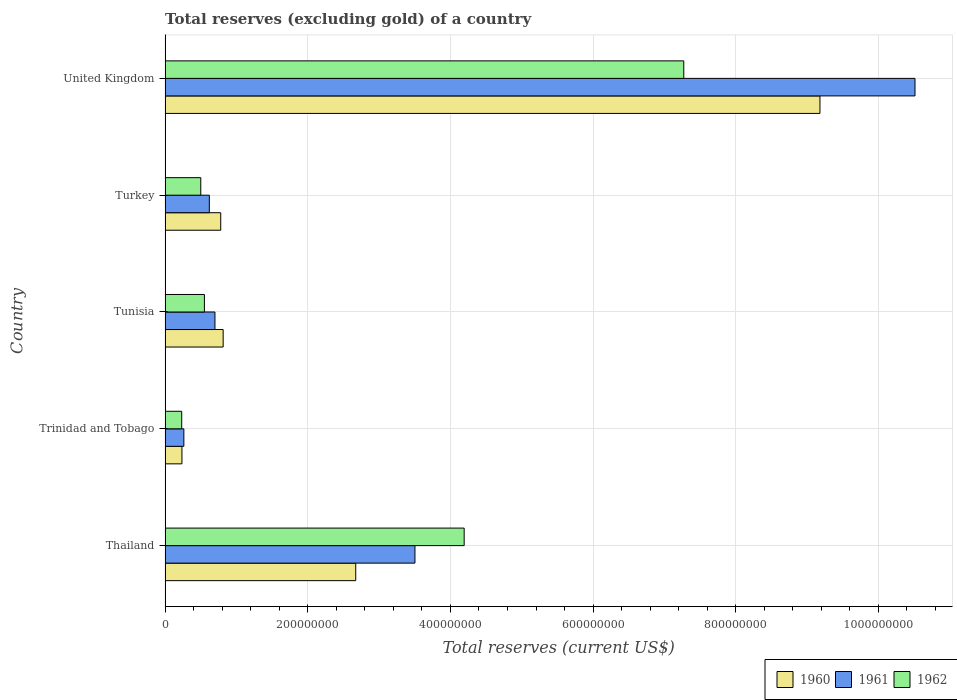How many groups of bars are there?
Your answer should be very brief. 5. Are the number of bars per tick equal to the number of legend labels?
Make the answer very short. Yes. Are the number of bars on each tick of the Y-axis equal?
Offer a very short reply. Yes. What is the label of the 3rd group of bars from the top?
Your answer should be very brief. Tunisia. What is the total reserves (excluding gold) in 1962 in Tunisia?
Your answer should be very brief. 5.51e+07. Across all countries, what is the maximum total reserves (excluding gold) in 1960?
Your response must be concise. 9.18e+08. Across all countries, what is the minimum total reserves (excluding gold) in 1960?
Your answer should be very brief. 2.36e+07. In which country was the total reserves (excluding gold) in 1962 maximum?
Provide a succinct answer. United Kingdom. In which country was the total reserves (excluding gold) in 1962 minimum?
Provide a succinct answer. Trinidad and Tobago. What is the total total reserves (excluding gold) in 1960 in the graph?
Provide a succinct answer. 1.37e+09. What is the difference between the total reserves (excluding gold) in 1961 in Trinidad and Tobago and that in United Kingdom?
Your answer should be very brief. -1.02e+09. What is the difference between the total reserves (excluding gold) in 1960 in Trinidad and Tobago and the total reserves (excluding gold) in 1961 in Turkey?
Your answer should be compact. -3.84e+07. What is the average total reserves (excluding gold) in 1962 per country?
Make the answer very short. 2.55e+08. What is the difference between the total reserves (excluding gold) in 1960 and total reserves (excluding gold) in 1961 in Thailand?
Offer a very short reply. -8.30e+07. In how many countries, is the total reserves (excluding gold) in 1962 greater than 80000000 US$?
Offer a terse response. 2. What is the ratio of the total reserves (excluding gold) in 1960 in Thailand to that in Turkey?
Your answer should be very brief. 3.43. What is the difference between the highest and the second highest total reserves (excluding gold) in 1962?
Offer a terse response. 3.08e+08. What is the difference between the highest and the lowest total reserves (excluding gold) in 1960?
Your response must be concise. 8.94e+08. How many countries are there in the graph?
Offer a very short reply. 5. Are the values on the major ticks of X-axis written in scientific E-notation?
Your answer should be very brief. No. Does the graph contain any zero values?
Make the answer very short. No. Does the graph contain grids?
Offer a very short reply. Yes. How many legend labels are there?
Offer a terse response. 3. What is the title of the graph?
Offer a very short reply. Total reserves (excluding gold) of a country. Does "2010" appear as one of the legend labels in the graph?
Make the answer very short. No. What is the label or title of the X-axis?
Keep it short and to the point. Total reserves (current US$). What is the Total reserves (current US$) of 1960 in Thailand?
Your answer should be compact. 2.67e+08. What is the Total reserves (current US$) of 1961 in Thailand?
Ensure brevity in your answer.  3.50e+08. What is the Total reserves (current US$) in 1962 in Thailand?
Keep it short and to the point. 4.19e+08. What is the Total reserves (current US$) in 1960 in Trinidad and Tobago?
Offer a very short reply. 2.36e+07. What is the Total reserves (current US$) of 1961 in Trinidad and Tobago?
Your answer should be compact. 2.63e+07. What is the Total reserves (current US$) of 1962 in Trinidad and Tobago?
Your answer should be compact. 2.33e+07. What is the Total reserves (current US$) of 1960 in Tunisia?
Your response must be concise. 8.14e+07. What is the Total reserves (current US$) in 1961 in Tunisia?
Offer a very short reply. 6.99e+07. What is the Total reserves (current US$) in 1962 in Tunisia?
Offer a terse response. 5.51e+07. What is the Total reserves (current US$) in 1960 in Turkey?
Provide a short and direct response. 7.80e+07. What is the Total reserves (current US$) in 1961 in Turkey?
Provide a succinct answer. 6.20e+07. What is the Total reserves (current US$) in 1960 in United Kingdom?
Your answer should be compact. 9.18e+08. What is the Total reserves (current US$) of 1961 in United Kingdom?
Keep it short and to the point. 1.05e+09. What is the Total reserves (current US$) in 1962 in United Kingdom?
Your answer should be very brief. 7.27e+08. Across all countries, what is the maximum Total reserves (current US$) of 1960?
Offer a very short reply. 9.18e+08. Across all countries, what is the maximum Total reserves (current US$) of 1961?
Your response must be concise. 1.05e+09. Across all countries, what is the maximum Total reserves (current US$) in 1962?
Ensure brevity in your answer.  7.27e+08. Across all countries, what is the minimum Total reserves (current US$) in 1960?
Keep it short and to the point. 2.36e+07. Across all countries, what is the minimum Total reserves (current US$) of 1961?
Make the answer very short. 2.63e+07. Across all countries, what is the minimum Total reserves (current US$) of 1962?
Offer a terse response. 2.33e+07. What is the total Total reserves (current US$) of 1960 in the graph?
Offer a terse response. 1.37e+09. What is the total Total reserves (current US$) of 1961 in the graph?
Provide a succinct answer. 1.56e+09. What is the total Total reserves (current US$) in 1962 in the graph?
Your answer should be compact. 1.27e+09. What is the difference between the Total reserves (current US$) in 1960 in Thailand and that in Trinidad and Tobago?
Provide a succinct answer. 2.44e+08. What is the difference between the Total reserves (current US$) of 1961 in Thailand and that in Trinidad and Tobago?
Your answer should be compact. 3.24e+08. What is the difference between the Total reserves (current US$) in 1962 in Thailand and that in Trinidad and Tobago?
Give a very brief answer. 3.96e+08. What is the difference between the Total reserves (current US$) in 1960 in Thailand and that in Tunisia?
Your response must be concise. 1.86e+08. What is the difference between the Total reserves (current US$) of 1961 in Thailand and that in Tunisia?
Offer a very short reply. 2.80e+08. What is the difference between the Total reserves (current US$) in 1962 in Thailand and that in Tunisia?
Give a very brief answer. 3.64e+08. What is the difference between the Total reserves (current US$) of 1960 in Thailand and that in Turkey?
Make the answer very short. 1.89e+08. What is the difference between the Total reserves (current US$) of 1961 in Thailand and that in Turkey?
Offer a very short reply. 2.88e+08. What is the difference between the Total reserves (current US$) in 1962 in Thailand and that in Turkey?
Offer a very short reply. 3.69e+08. What is the difference between the Total reserves (current US$) of 1960 in Thailand and that in United Kingdom?
Provide a succinct answer. -6.51e+08. What is the difference between the Total reserves (current US$) of 1961 in Thailand and that in United Kingdom?
Offer a very short reply. -7.01e+08. What is the difference between the Total reserves (current US$) of 1962 in Thailand and that in United Kingdom?
Keep it short and to the point. -3.08e+08. What is the difference between the Total reserves (current US$) of 1960 in Trinidad and Tobago and that in Tunisia?
Give a very brief answer. -5.78e+07. What is the difference between the Total reserves (current US$) in 1961 in Trinidad and Tobago and that in Tunisia?
Your response must be concise. -4.36e+07. What is the difference between the Total reserves (current US$) in 1962 in Trinidad and Tobago and that in Tunisia?
Ensure brevity in your answer.  -3.18e+07. What is the difference between the Total reserves (current US$) in 1960 in Trinidad and Tobago and that in Turkey?
Offer a terse response. -5.44e+07. What is the difference between the Total reserves (current US$) of 1961 in Trinidad and Tobago and that in Turkey?
Ensure brevity in your answer.  -3.57e+07. What is the difference between the Total reserves (current US$) in 1962 in Trinidad and Tobago and that in Turkey?
Provide a short and direct response. -2.67e+07. What is the difference between the Total reserves (current US$) in 1960 in Trinidad and Tobago and that in United Kingdom?
Your answer should be compact. -8.94e+08. What is the difference between the Total reserves (current US$) of 1961 in Trinidad and Tobago and that in United Kingdom?
Ensure brevity in your answer.  -1.02e+09. What is the difference between the Total reserves (current US$) in 1962 in Trinidad and Tobago and that in United Kingdom?
Your response must be concise. -7.04e+08. What is the difference between the Total reserves (current US$) in 1960 in Tunisia and that in Turkey?
Keep it short and to the point. 3.40e+06. What is the difference between the Total reserves (current US$) of 1961 in Tunisia and that in Turkey?
Give a very brief answer. 7.90e+06. What is the difference between the Total reserves (current US$) of 1962 in Tunisia and that in Turkey?
Offer a terse response. 5.10e+06. What is the difference between the Total reserves (current US$) in 1960 in Tunisia and that in United Kingdom?
Offer a terse response. -8.37e+08. What is the difference between the Total reserves (current US$) of 1961 in Tunisia and that in United Kingdom?
Provide a short and direct response. -9.81e+08. What is the difference between the Total reserves (current US$) in 1962 in Tunisia and that in United Kingdom?
Offer a terse response. -6.72e+08. What is the difference between the Total reserves (current US$) of 1960 in Turkey and that in United Kingdom?
Your answer should be compact. -8.40e+08. What is the difference between the Total reserves (current US$) of 1961 in Turkey and that in United Kingdom?
Keep it short and to the point. -9.89e+08. What is the difference between the Total reserves (current US$) in 1962 in Turkey and that in United Kingdom?
Give a very brief answer. -6.77e+08. What is the difference between the Total reserves (current US$) of 1960 in Thailand and the Total reserves (current US$) of 1961 in Trinidad and Tobago?
Your response must be concise. 2.41e+08. What is the difference between the Total reserves (current US$) of 1960 in Thailand and the Total reserves (current US$) of 1962 in Trinidad and Tobago?
Provide a succinct answer. 2.44e+08. What is the difference between the Total reserves (current US$) of 1961 in Thailand and the Total reserves (current US$) of 1962 in Trinidad and Tobago?
Your answer should be compact. 3.27e+08. What is the difference between the Total reserves (current US$) in 1960 in Thailand and the Total reserves (current US$) in 1961 in Tunisia?
Your response must be concise. 1.97e+08. What is the difference between the Total reserves (current US$) of 1960 in Thailand and the Total reserves (current US$) of 1962 in Tunisia?
Keep it short and to the point. 2.12e+08. What is the difference between the Total reserves (current US$) of 1961 in Thailand and the Total reserves (current US$) of 1962 in Tunisia?
Provide a short and direct response. 2.95e+08. What is the difference between the Total reserves (current US$) of 1960 in Thailand and the Total reserves (current US$) of 1961 in Turkey?
Ensure brevity in your answer.  2.05e+08. What is the difference between the Total reserves (current US$) in 1960 in Thailand and the Total reserves (current US$) in 1962 in Turkey?
Provide a short and direct response. 2.17e+08. What is the difference between the Total reserves (current US$) in 1961 in Thailand and the Total reserves (current US$) in 1962 in Turkey?
Your answer should be very brief. 3.00e+08. What is the difference between the Total reserves (current US$) in 1960 in Thailand and the Total reserves (current US$) in 1961 in United Kingdom?
Your response must be concise. -7.84e+08. What is the difference between the Total reserves (current US$) of 1960 in Thailand and the Total reserves (current US$) of 1962 in United Kingdom?
Your answer should be compact. -4.60e+08. What is the difference between the Total reserves (current US$) in 1961 in Thailand and the Total reserves (current US$) in 1962 in United Kingdom?
Your answer should be compact. -3.77e+08. What is the difference between the Total reserves (current US$) of 1960 in Trinidad and Tobago and the Total reserves (current US$) of 1961 in Tunisia?
Provide a succinct answer. -4.63e+07. What is the difference between the Total reserves (current US$) in 1960 in Trinidad and Tobago and the Total reserves (current US$) in 1962 in Tunisia?
Your response must be concise. -3.15e+07. What is the difference between the Total reserves (current US$) of 1961 in Trinidad and Tobago and the Total reserves (current US$) of 1962 in Tunisia?
Make the answer very short. -2.88e+07. What is the difference between the Total reserves (current US$) of 1960 in Trinidad and Tobago and the Total reserves (current US$) of 1961 in Turkey?
Ensure brevity in your answer.  -3.84e+07. What is the difference between the Total reserves (current US$) of 1960 in Trinidad and Tobago and the Total reserves (current US$) of 1962 in Turkey?
Provide a short and direct response. -2.64e+07. What is the difference between the Total reserves (current US$) in 1961 in Trinidad and Tobago and the Total reserves (current US$) in 1962 in Turkey?
Give a very brief answer. -2.37e+07. What is the difference between the Total reserves (current US$) of 1960 in Trinidad and Tobago and the Total reserves (current US$) of 1961 in United Kingdom?
Your answer should be compact. -1.03e+09. What is the difference between the Total reserves (current US$) in 1960 in Trinidad and Tobago and the Total reserves (current US$) in 1962 in United Kingdom?
Your answer should be very brief. -7.04e+08. What is the difference between the Total reserves (current US$) of 1961 in Trinidad and Tobago and the Total reserves (current US$) of 1962 in United Kingdom?
Your answer should be very brief. -7.01e+08. What is the difference between the Total reserves (current US$) in 1960 in Tunisia and the Total reserves (current US$) in 1961 in Turkey?
Your answer should be very brief. 1.94e+07. What is the difference between the Total reserves (current US$) of 1960 in Tunisia and the Total reserves (current US$) of 1962 in Turkey?
Your answer should be compact. 3.14e+07. What is the difference between the Total reserves (current US$) in 1961 in Tunisia and the Total reserves (current US$) in 1962 in Turkey?
Give a very brief answer. 1.99e+07. What is the difference between the Total reserves (current US$) of 1960 in Tunisia and the Total reserves (current US$) of 1961 in United Kingdom?
Give a very brief answer. -9.70e+08. What is the difference between the Total reserves (current US$) of 1960 in Tunisia and the Total reserves (current US$) of 1962 in United Kingdom?
Make the answer very short. -6.46e+08. What is the difference between the Total reserves (current US$) in 1961 in Tunisia and the Total reserves (current US$) in 1962 in United Kingdom?
Your answer should be very brief. -6.57e+08. What is the difference between the Total reserves (current US$) of 1960 in Turkey and the Total reserves (current US$) of 1961 in United Kingdom?
Give a very brief answer. -9.73e+08. What is the difference between the Total reserves (current US$) of 1960 in Turkey and the Total reserves (current US$) of 1962 in United Kingdom?
Your answer should be compact. -6.49e+08. What is the difference between the Total reserves (current US$) of 1961 in Turkey and the Total reserves (current US$) of 1962 in United Kingdom?
Offer a very short reply. -6.65e+08. What is the average Total reserves (current US$) in 1960 per country?
Ensure brevity in your answer.  2.74e+08. What is the average Total reserves (current US$) of 1961 per country?
Offer a terse response. 3.12e+08. What is the average Total reserves (current US$) in 1962 per country?
Ensure brevity in your answer.  2.55e+08. What is the difference between the Total reserves (current US$) in 1960 and Total reserves (current US$) in 1961 in Thailand?
Offer a terse response. -8.30e+07. What is the difference between the Total reserves (current US$) in 1960 and Total reserves (current US$) in 1962 in Thailand?
Your answer should be compact. -1.52e+08. What is the difference between the Total reserves (current US$) in 1961 and Total reserves (current US$) in 1962 in Thailand?
Your response must be concise. -6.90e+07. What is the difference between the Total reserves (current US$) in 1960 and Total reserves (current US$) in 1961 in Trinidad and Tobago?
Your answer should be very brief. -2.70e+06. What is the difference between the Total reserves (current US$) in 1960 and Total reserves (current US$) in 1961 in Tunisia?
Provide a succinct answer. 1.15e+07. What is the difference between the Total reserves (current US$) in 1960 and Total reserves (current US$) in 1962 in Tunisia?
Provide a short and direct response. 2.63e+07. What is the difference between the Total reserves (current US$) of 1961 and Total reserves (current US$) of 1962 in Tunisia?
Provide a short and direct response. 1.48e+07. What is the difference between the Total reserves (current US$) of 1960 and Total reserves (current US$) of 1961 in Turkey?
Your answer should be compact. 1.60e+07. What is the difference between the Total reserves (current US$) of 1960 and Total reserves (current US$) of 1962 in Turkey?
Keep it short and to the point. 2.80e+07. What is the difference between the Total reserves (current US$) of 1961 and Total reserves (current US$) of 1962 in Turkey?
Your answer should be very brief. 1.20e+07. What is the difference between the Total reserves (current US$) in 1960 and Total reserves (current US$) in 1961 in United Kingdom?
Your answer should be very brief. -1.33e+08. What is the difference between the Total reserves (current US$) of 1960 and Total reserves (current US$) of 1962 in United Kingdom?
Offer a very short reply. 1.91e+08. What is the difference between the Total reserves (current US$) in 1961 and Total reserves (current US$) in 1962 in United Kingdom?
Your response must be concise. 3.24e+08. What is the ratio of the Total reserves (current US$) in 1960 in Thailand to that in Trinidad and Tobago?
Offer a very short reply. 11.32. What is the ratio of the Total reserves (current US$) of 1961 in Thailand to that in Trinidad and Tobago?
Your answer should be very brief. 13.32. What is the ratio of the Total reserves (current US$) in 1962 in Thailand to that in Trinidad and Tobago?
Your response must be concise. 17.99. What is the ratio of the Total reserves (current US$) in 1960 in Thailand to that in Tunisia?
Your response must be concise. 3.28. What is the ratio of the Total reserves (current US$) in 1961 in Thailand to that in Tunisia?
Your response must be concise. 5.01. What is the ratio of the Total reserves (current US$) in 1962 in Thailand to that in Tunisia?
Offer a terse response. 7.61. What is the ratio of the Total reserves (current US$) of 1960 in Thailand to that in Turkey?
Offer a very short reply. 3.43. What is the ratio of the Total reserves (current US$) of 1961 in Thailand to that in Turkey?
Ensure brevity in your answer.  5.65. What is the ratio of the Total reserves (current US$) of 1962 in Thailand to that in Turkey?
Ensure brevity in your answer.  8.39. What is the ratio of the Total reserves (current US$) of 1960 in Thailand to that in United Kingdom?
Your response must be concise. 0.29. What is the ratio of the Total reserves (current US$) of 1961 in Thailand to that in United Kingdom?
Provide a succinct answer. 0.33. What is the ratio of the Total reserves (current US$) of 1962 in Thailand to that in United Kingdom?
Provide a succinct answer. 0.58. What is the ratio of the Total reserves (current US$) in 1960 in Trinidad and Tobago to that in Tunisia?
Give a very brief answer. 0.29. What is the ratio of the Total reserves (current US$) in 1961 in Trinidad and Tobago to that in Tunisia?
Your answer should be compact. 0.38. What is the ratio of the Total reserves (current US$) in 1962 in Trinidad and Tobago to that in Tunisia?
Your answer should be compact. 0.42. What is the ratio of the Total reserves (current US$) in 1960 in Trinidad and Tobago to that in Turkey?
Offer a terse response. 0.3. What is the ratio of the Total reserves (current US$) of 1961 in Trinidad and Tobago to that in Turkey?
Offer a very short reply. 0.42. What is the ratio of the Total reserves (current US$) of 1962 in Trinidad and Tobago to that in Turkey?
Give a very brief answer. 0.47. What is the ratio of the Total reserves (current US$) in 1960 in Trinidad and Tobago to that in United Kingdom?
Keep it short and to the point. 0.03. What is the ratio of the Total reserves (current US$) of 1961 in Trinidad and Tobago to that in United Kingdom?
Ensure brevity in your answer.  0.03. What is the ratio of the Total reserves (current US$) in 1962 in Trinidad and Tobago to that in United Kingdom?
Ensure brevity in your answer.  0.03. What is the ratio of the Total reserves (current US$) in 1960 in Tunisia to that in Turkey?
Offer a terse response. 1.04. What is the ratio of the Total reserves (current US$) of 1961 in Tunisia to that in Turkey?
Make the answer very short. 1.13. What is the ratio of the Total reserves (current US$) in 1962 in Tunisia to that in Turkey?
Offer a very short reply. 1.1. What is the ratio of the Total reserves (current US$) of 1960 in Tunisia to that in United Kingdom?
Offer a very short reply. 0.09. What is the ratio of the Total reserves (current US$) in 1961 in Tunisia to that in United Kingdom?
Make the answer very short. 0.07. What is the ratio of the Total reserves (current US$) in 1962 in Tunisia to that in United Kingdom?
Your answer should be compact. 0.08. What is the ratio of the Total reserves (current US$) of 1960 in Turkey to that in United Kingdom?
Provide a succinct answer. 0.09. What is the ratio of the Total reserves (current US$) of 1961 in Turkey to that in United Kingdom?
Your answer should be compact. 0.06. What is the ratio of the Total reserves (current US$) of 1962 in Turkey to that in United Kingdom?
Offer a terse response. 0.07. What is the difference between the highest and the second highest Total reserves (current US$) in 1960?
Offer a terse response. 6.51e+08. What is the difference between the highest and the second highest Total reserves (current US$) in 1961?
Your answer should be very brief. 7.01e+08. What is the difference between the highest and the second highest Total reserves (current US$) in 1962?
Your answer should be compact. 3.08e+08. What is the difference between the highest and the lowest Total reserves (current US$) of 1960?
Keep it short and to the point. 8.94e+08. What is the difference between the highest and the lowest Total reserves (current US$) of 1961?
Provide a succinct answer. 1.02e+09. What is the difference between the highest and the lowest Total reserves (current US$) in 1962?
Provide a succinct answer. 7.04e+08. 